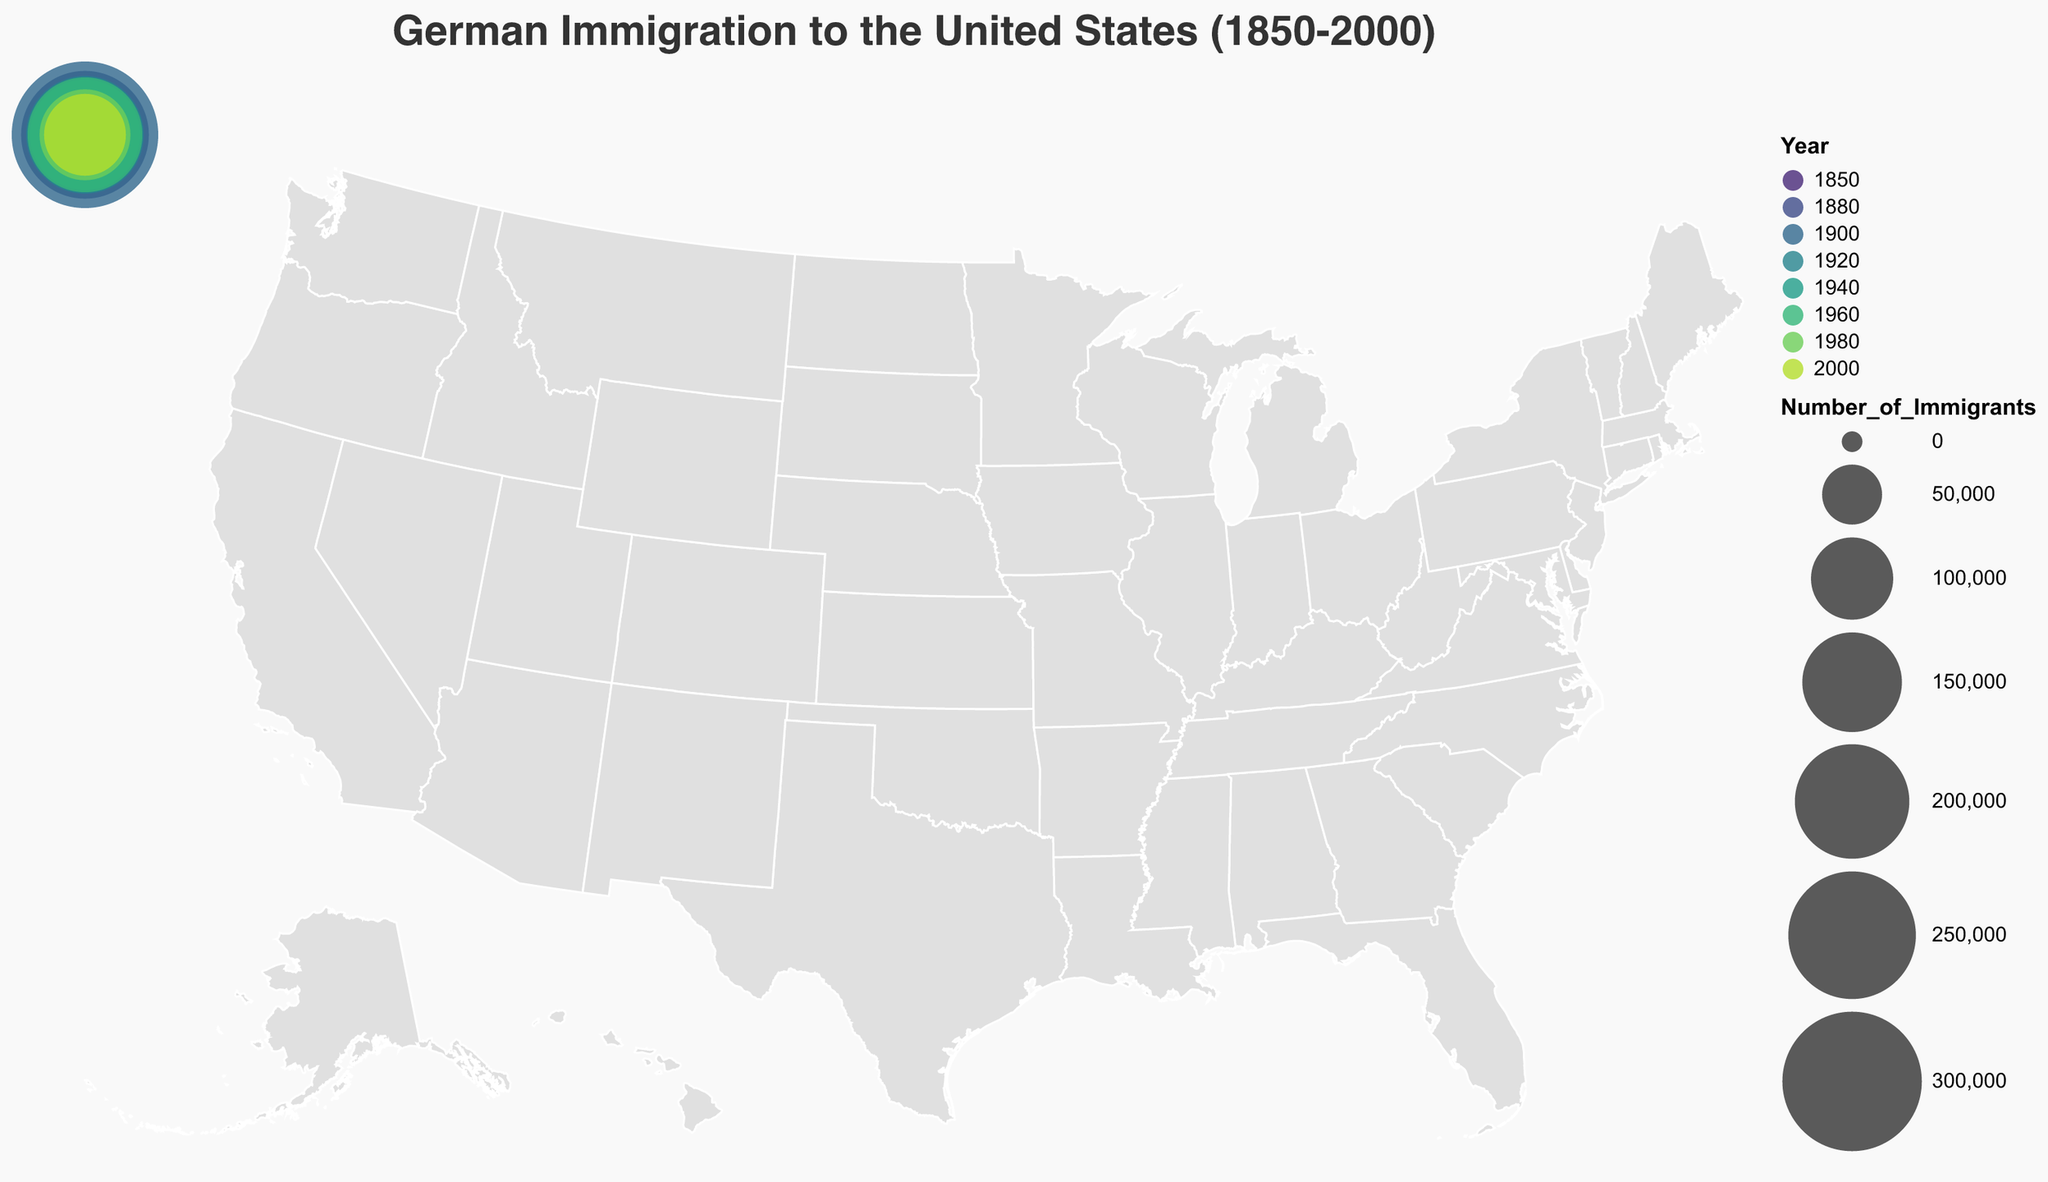What is the title of the figure? The title is located at the top of the figure and reads "German Immigration to the United States (1850-2000)".
Answer: German Immigration to the United States (1850-2000) Which state had the highest number of German immigrants in 1900? By examining the circle sizes and hovering over the data points, you can see that Illinois had the largest circle in the year 1900, corresponding to the highest number of immigrants.
Answer: Illinois What color represents the year 1960? The color scheme is viridis as indicated by the figure, and by locating the 1960 data point, you can observe the specific shade used.
Answer: It is a specific shade of green (viridis) Which two states had the most German immigrants in 1880 and 2000, respectively? By hovering over the data points, you can see that in 1880 the state with the most German immigrants is New York, and in 2000 it is Florida.
Answer: New York (1880) and Florida (2000) How did the number of German immigrants in Texas in 1980 compare to Florida in 2000? Comparing the sizes of the circles for Texas in 1980 and Florida in 2000, Texas had 123,560 immigrants and Florida had 98,813 immigrants. Therefore, Texas had more immigrants.
Answer: Texas had more immigrants than Florida What is the total number of German immigrants in Pennsylvania, New York, and Illinois in their respective years? The number of immigrants in Pennsylvania in 1850 is 78,570, in New York in 1880 is 250,630, and in Illinois in 1900 is 332,169. Summing these: 78570 + 250630 + 332169 = 661,369.
Answer: 661,369 In which decades did Ohio and Wisconsin see significant numbers of German immigrants, and how do these numbers compare? Ohio had significant German immigration in 1940 with 186,891 immigrants, while Wisconsin had significant immigration in 1920 with 211,140 immigrants. Wisconsin had more immigrants than Ohio.
Answer: Wisconsin in 1920 had more immigrants than Ohio in 1940 How did the trend of German immigration shift geographically from the 19th to the 20th century? Observing the data points, during the 19th century, immigration was higher in the northeastern and midwestern states (Pennsylvania, New York, Illinois). In the 20th century, there was more immigration to the western and southern states (California, Texas, Florida).
Answer: Shifted from northeastern/midwestern to western/southern states Which state had the lowest number of German immigrants in this data set, and in which year? By comparing all the data points, the smallest circle represents Florida in 2000 with 98,813 immigrants.
Answer: Florida in 2000 What is the average number of German immigrants in the states of California and Texas in their respective years? California in 1960 had 201,341 immigrants, and Texas in 1980 had 123,560 immigrants. The average is (201341 + 123560)/2 = 324901/2 = 162,450.5
Answer: 162,450.5 